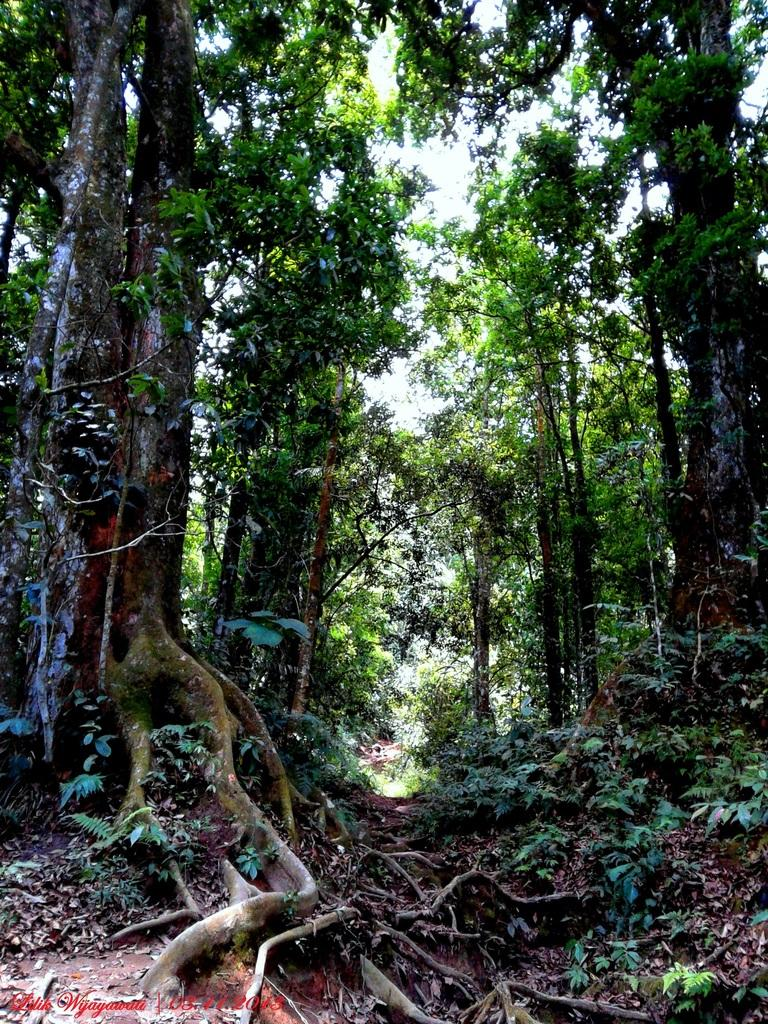What type of vegetation can be seen in the image? There are trees in the image. What is present on the surface in the image? Dry leaves are present on the surface in the image. How many sponges can be seen in the image? There are no sponges present in the image. What type of birds can be seen in the image? There are no birds present in the image. 